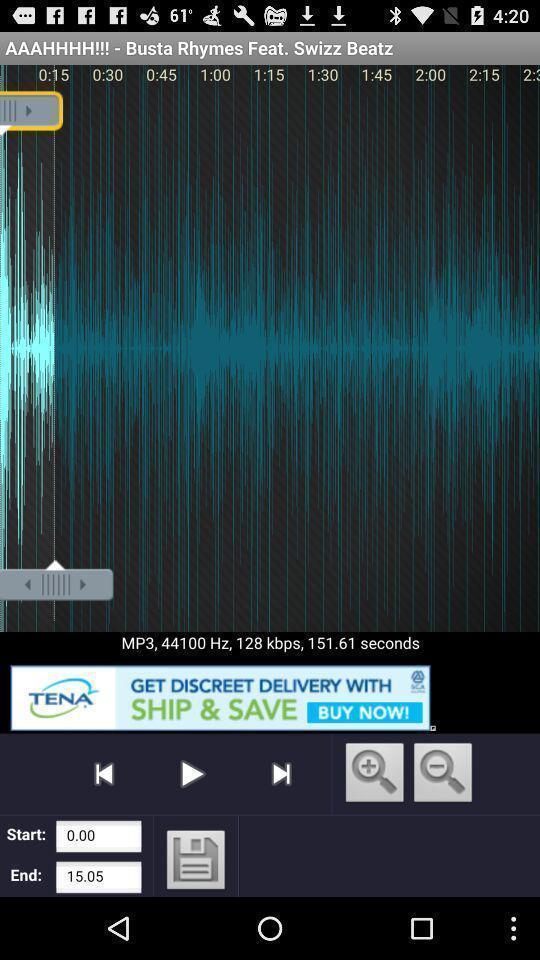Describe the visual elements of this screenshot. Screen showing a rhymes app on an android. 